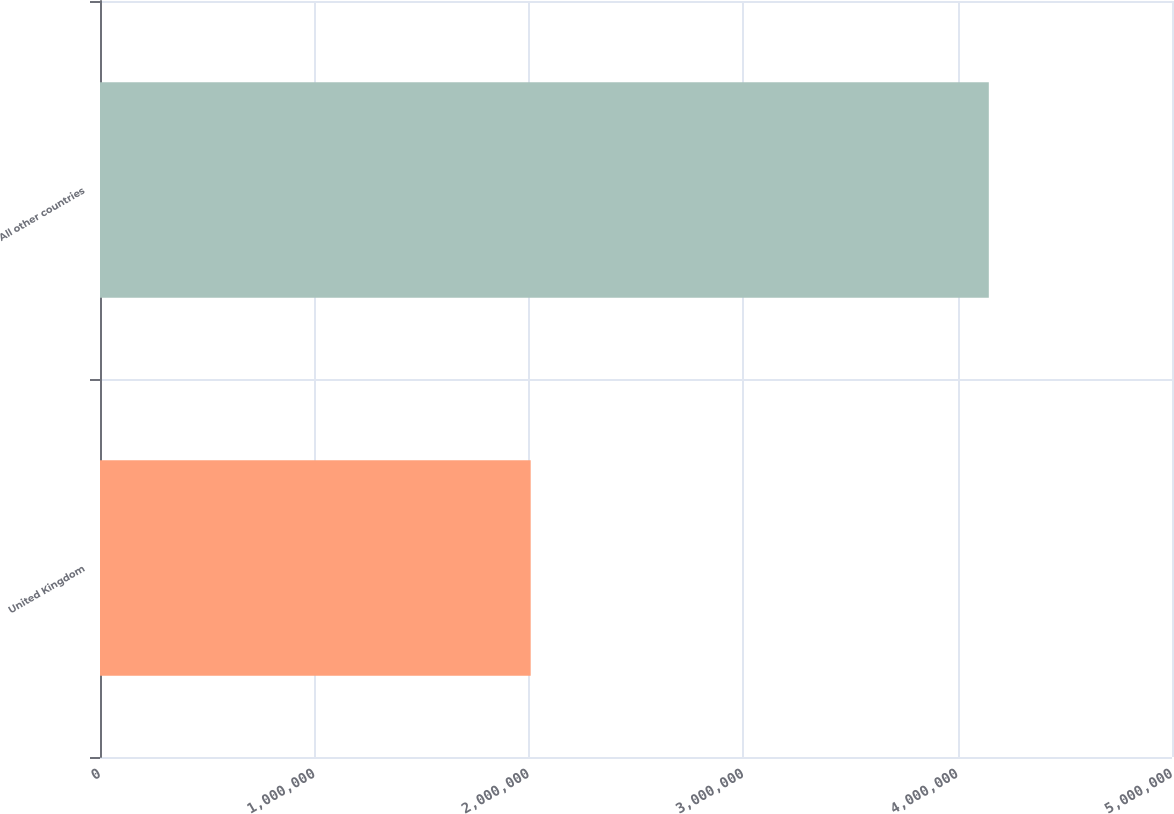Convert chart. <chart><loc_0><loc_0><loc_500><loc_500><bar_chart><fcel>United Kingdom<fcel>All other countries<nl><fcel>2.00878e+06<fcel>4.14559e+06<nl></chart> 